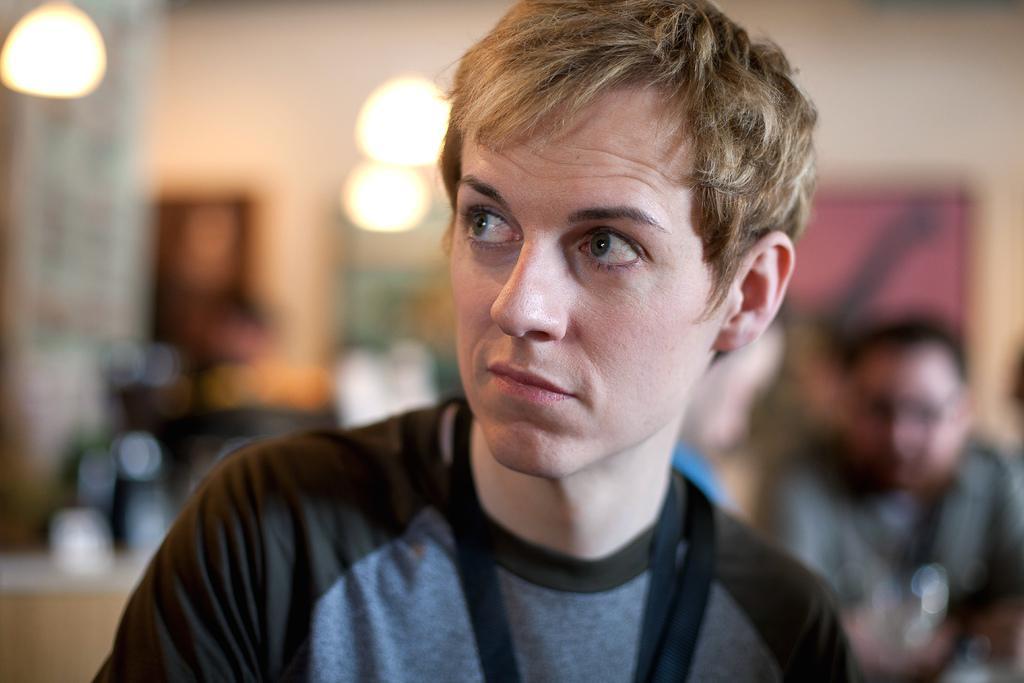How would you summarize this image in a sentence or two? In this image, we can see a person on blur background. There is an another person in the bottom right of the image. 